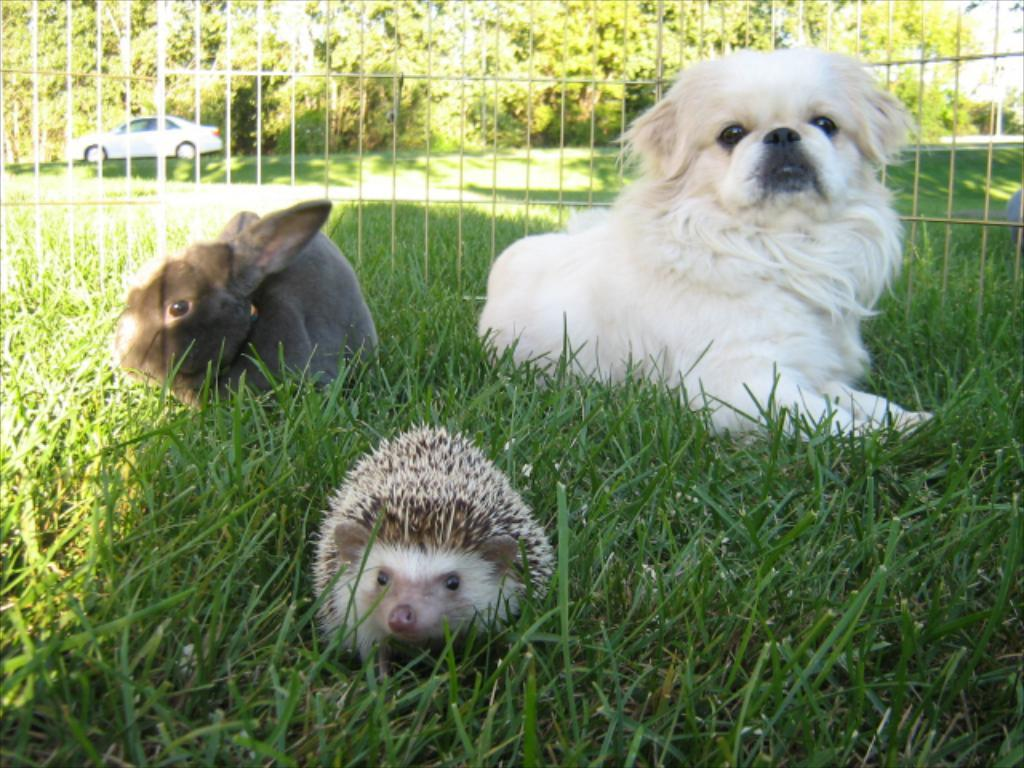What type of living organisms can be seen in the image? There are animals in the image. Where are the animals located? The animals are on the grass. What is the barrier surrounding the area where the animals are? There is mesh fencing in the image. What can be seen in the background of the image? There is a car and trees in the background of the image. How many fairies are flying around the animals in the image? There are no fairies present in the image. What is the distance between the animals and the car in the background? The distance between the animals and the car cannot be determined from the image alone, as there is no reference point to measure the distance accurately. 